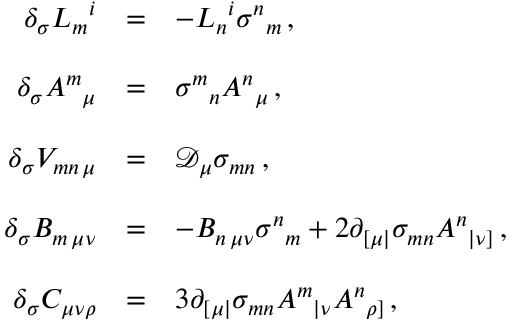Convert formula to latex. <formula><loc_0><loc_0><loc_500><loc_500>\begin{array} { r c l } { { \delta _ { \sigma } L _ { m ^ { i } } } & { = } & { { - L _ { n ^ { i } \sigma ^ { n _ { m } \, , } } \\ { { \delta _ { \sigma } A ^ { m _ { \mu } } } & { = } & { { \sigma ^ { m _ { n } A ^ { n _ { \mu } \, , } } \\ { { \delta _ { \sigma } V _ { m n \, \mu } } } & { = } & { { \mathcal { D } _ { \mu } \sigma _ { m n } \, , } } \\ { { \delta _ { \sigma } B _ { m \, \mu \nu } } } & { = } & { { - B _ { n \, \mu \nu } \sigma ^ { n _ { m } + 2 \partial _ { [ \mu | } \sigma _ { m n } A ^ { n _ { | \nu ] } \, , } } \\ { { \delta _ { \sigma } C _ { \mu \nu \rho } } } & { = } & { { 3 \partial _ { [ \mu | } \sigma _ { m n } A ^ { m _ { | \nu } A ^ { n _ { \rho ] } \, , } } \end{array}</formula> 